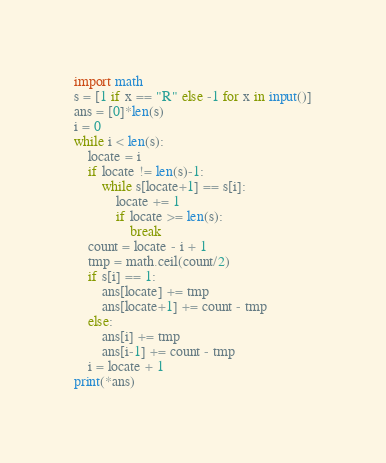Convert code to text. <code><loc_0><loc_0><loc_500><loc_500><_Python_>import math
s = [1 if x == "R" else -1 for x in input()]
ans = [0]*len(s)
i = 0
while i < len(s):
    locate = i
    if locate != len(s)-1:
        while s[locate+1] == s[i]:
            locate += 1
            if locate >= len(s):
                break
    count = locate - i + 1
    tmp = math.ceil(count/2)
    if s[i] == 1:
        ans[locate] += tmp
        ans[locate+1] += count - tmp
    else:
        ans[i] += tmp
        ans[i-1] += count - tmp
    i = locate + 1
print(*ans)
</code> 